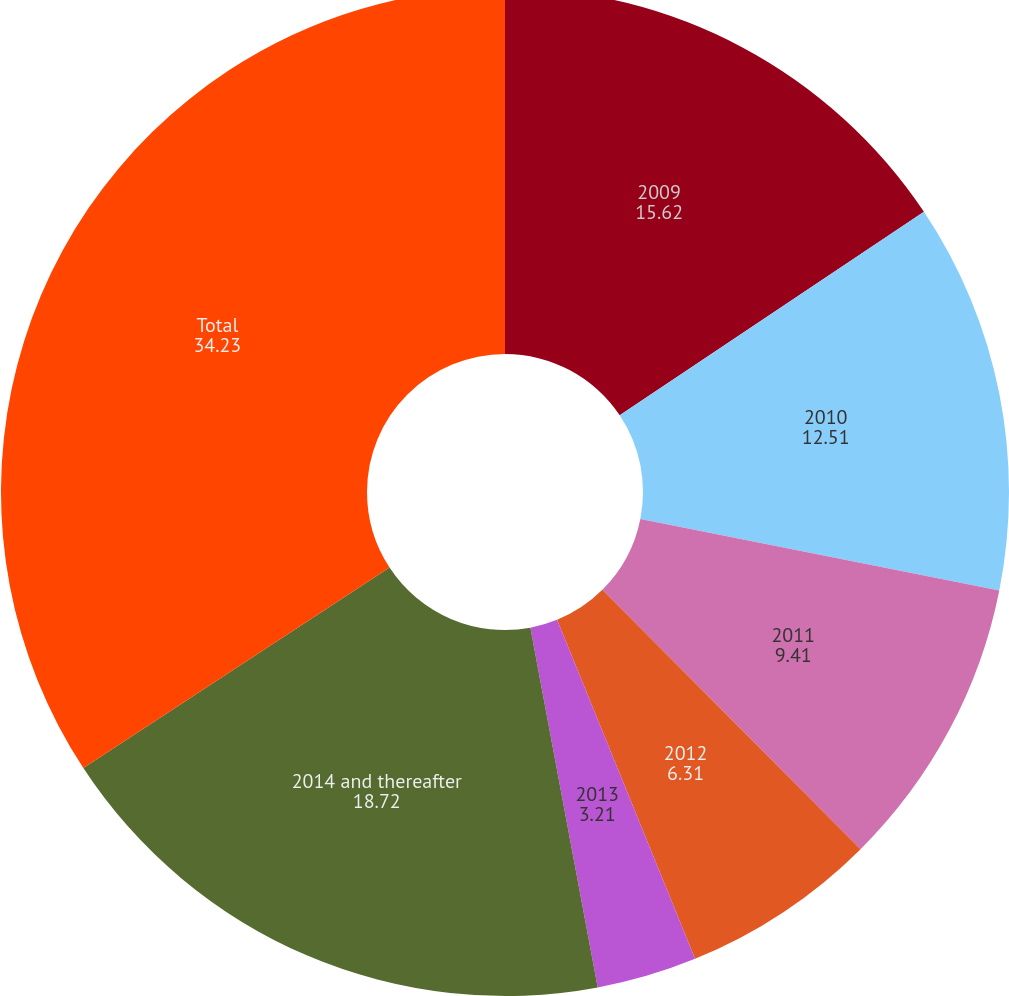<chart> <loc_0><loc_0><loc_500><loc_500><pie_chart><fcel>2009<fcel>2010<fcel>2011<fcel>2012<fcel>2013<fcel>2014 and thereafter<fcel>Total<nl><fcel>15.62%<fcel>12.51%<fcel>9.41%<fcel>6.31%<fcel>3.21%<fcel>18.72%<fcel>34.23%<nl></chart> 